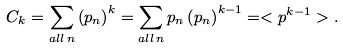<formula> <loc_0><loc_0><loc_500><loc_500>C _ { k } = \sum _ { a l l \, n } \left ( p _ { n } \right ) ^ { k } = \sum _ { a l l \, n } p _ { n } \left ( p _ { n } \right ) ^ { k - 1 } = < p ^ { k - 1 } > .</formula> 